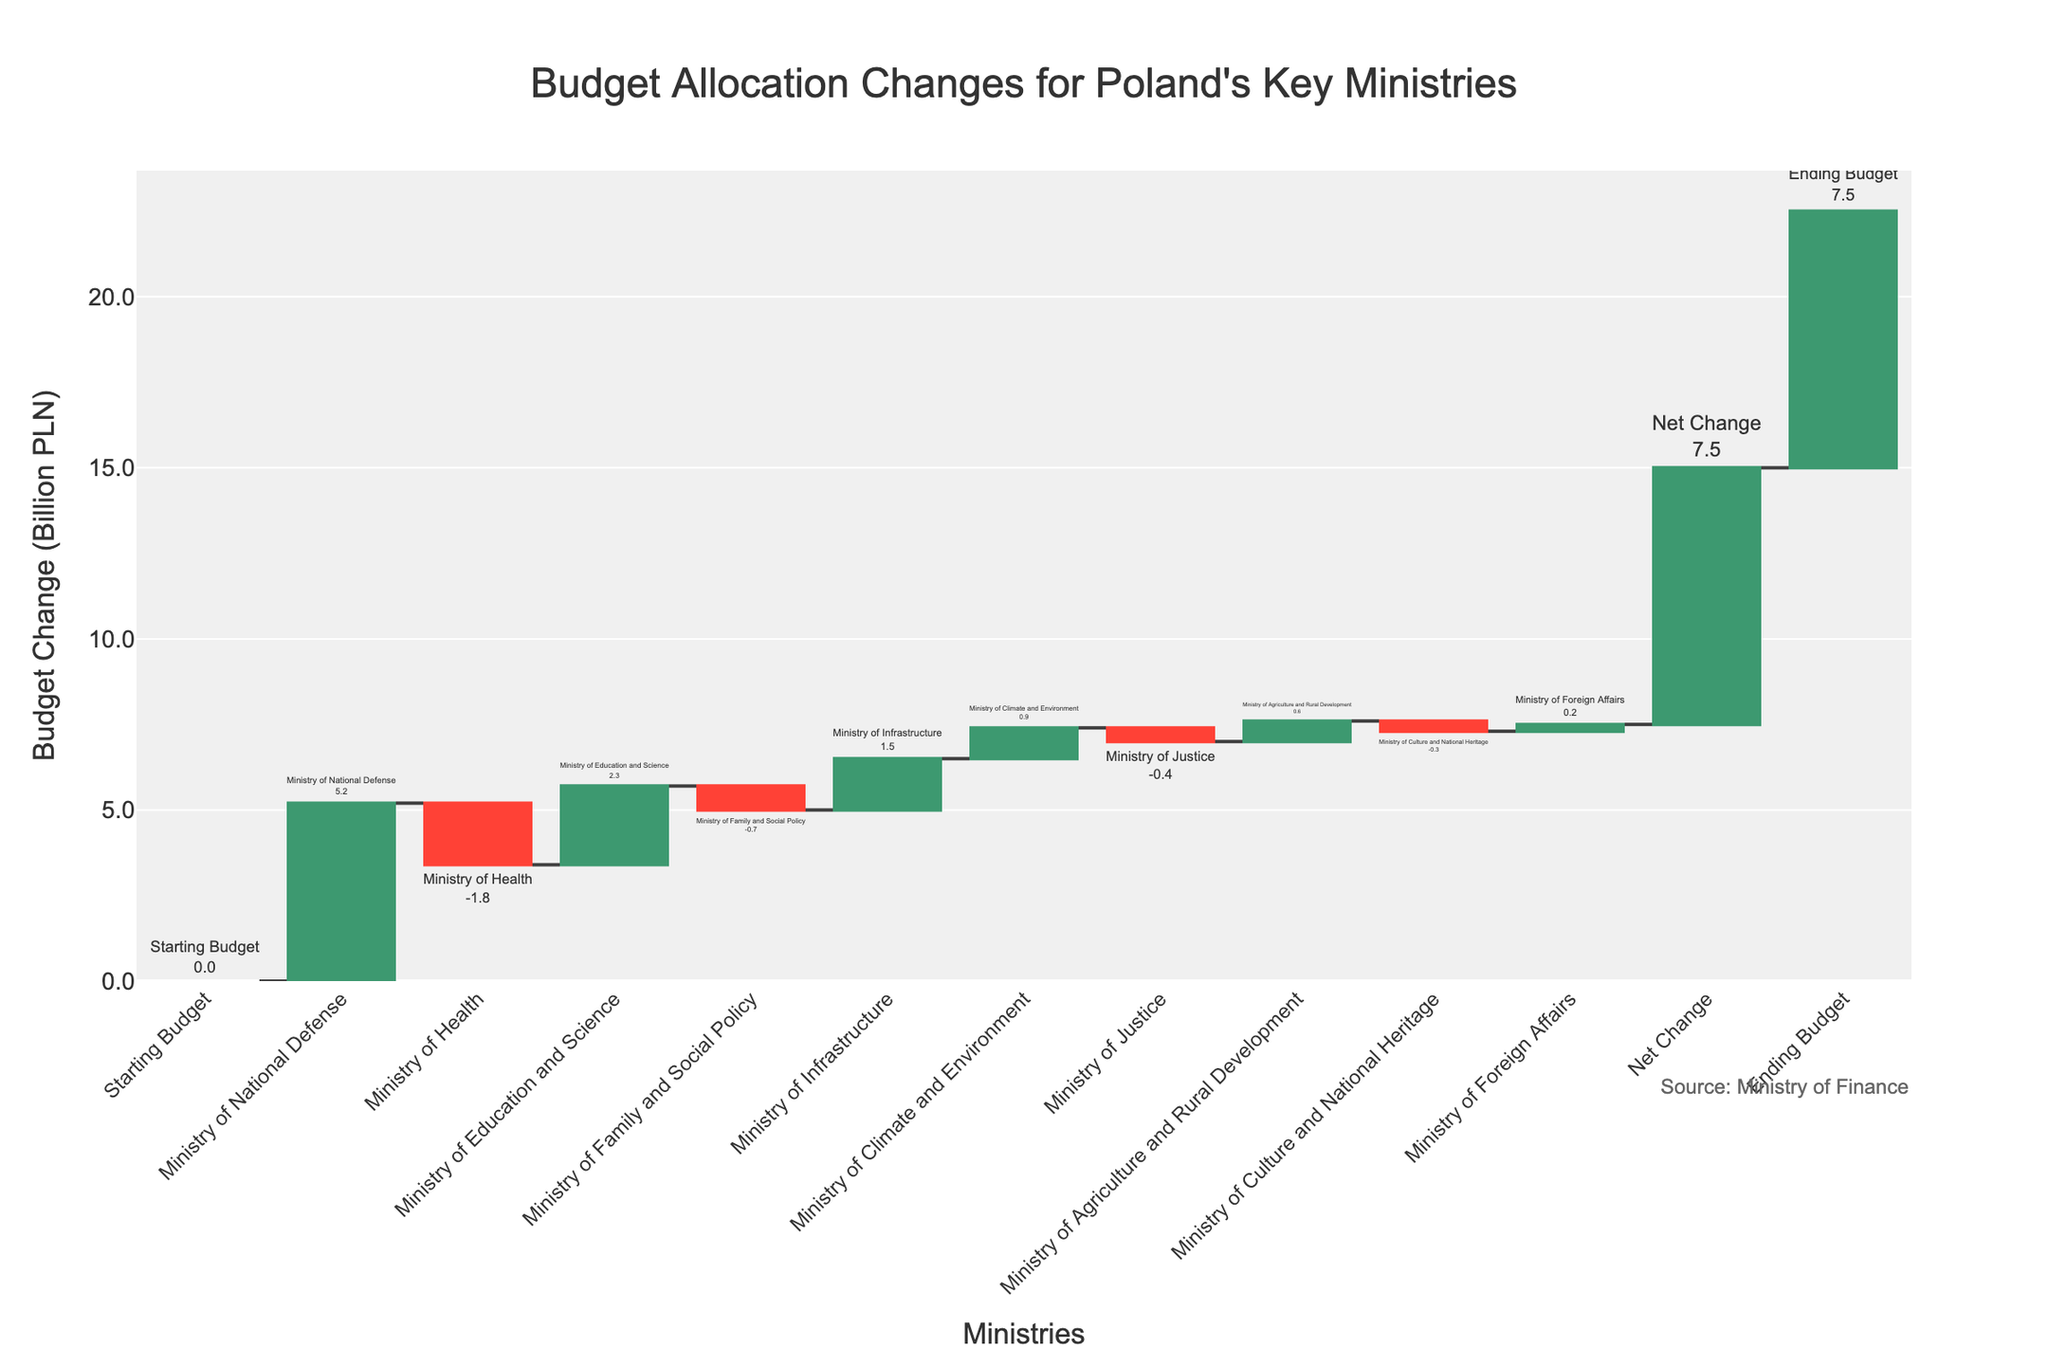What's the title of the chart? The title of the chart is located at the top and reads "Budget Allocation Changes for Poland's Key Ministries".
Answer: Budget Allocation Changes for Poland's Key Ministries How many ministries had budget increases? The bars colored in green represent positive changes, so you need to count these. They are for the Ministry of National Defense, Ministry of Education and Science, Ministry of Infrastructure, Ministry of Climate and Environment, Ministry of Agriculture and Rural Development, and Ministry of Foreign Affairs.
Answer: 6 Which ministry experienced the largest budget increase? The tallest green bar indicates the largest budget increase. This bar corresponds to the Ministry of National Defense with an increase of 5.2 billion PLN.
Answer: Ministry of National Defense Which ministry had the highest budget decrease? The tallest red bar shows the largest decrease, which is the Ministry of Health with a decrease of 1.8 billion PLN.
Answer: Ministry of Health By how much did the budget change for the Ministry of Justice? The bar representing the Ministry of Justice indicates a budget change. The value specified is -0.4 billion PLN.
Answer: -0.4 billion PLN How does the budget change for the Ministry of Climate and Environment compare to that of the Ministry of Health? The Ministry of Climate and Environment has a positive change of +0.9 billion PLN, while the Ministry of Health has a negative change of -1.8 billion PLN. This indicates that the Ministry of Climate and Environment had an increase and the Ministry of Health had a decrease.
Answer: Ministry of Climate and Environment increased; Ministry of Health decreased What is the net change in the budget after all the adjustments? The net change is depicted as a separate bar called "Net Change," and its value is 7.5 billion PLN.
Answer: 7.5 billion PLN What is the final, or ending, budget after all adjustments? The ending budget is represented by the final bar, labeled "Ending Budget," and the value is 7.5 billion PLN.
Answer: 7.5 billion PLN What is the combined budget change for the Ministry of Education and Science and the Ministry of Family and Social Policy? Adding the budget changes for these two ministries: +2.3 billion PLN for the Ministry of Education and Science and -0.7 billion PLN for the Ministry of Family and Social Policy, results in a combined change of +1.6 billion PLN.
Answer: +1.6 billion PLN Which of the ministries had a smaller decrease in budget, the Ministry of Justice or the Ministry of Culture and National Heritage? The Ministry of Justice has a decrease of -0.4 billion PLN, while the Ministry of Culture and National Heritage has a decrease of -0.3 billion PLN. Since -0.3 is smaller in magnitude than -0.4, the Ministry of Culture and National Heritage had a smaller decrease.
Answer: Ministry of Culture and National Heritage 